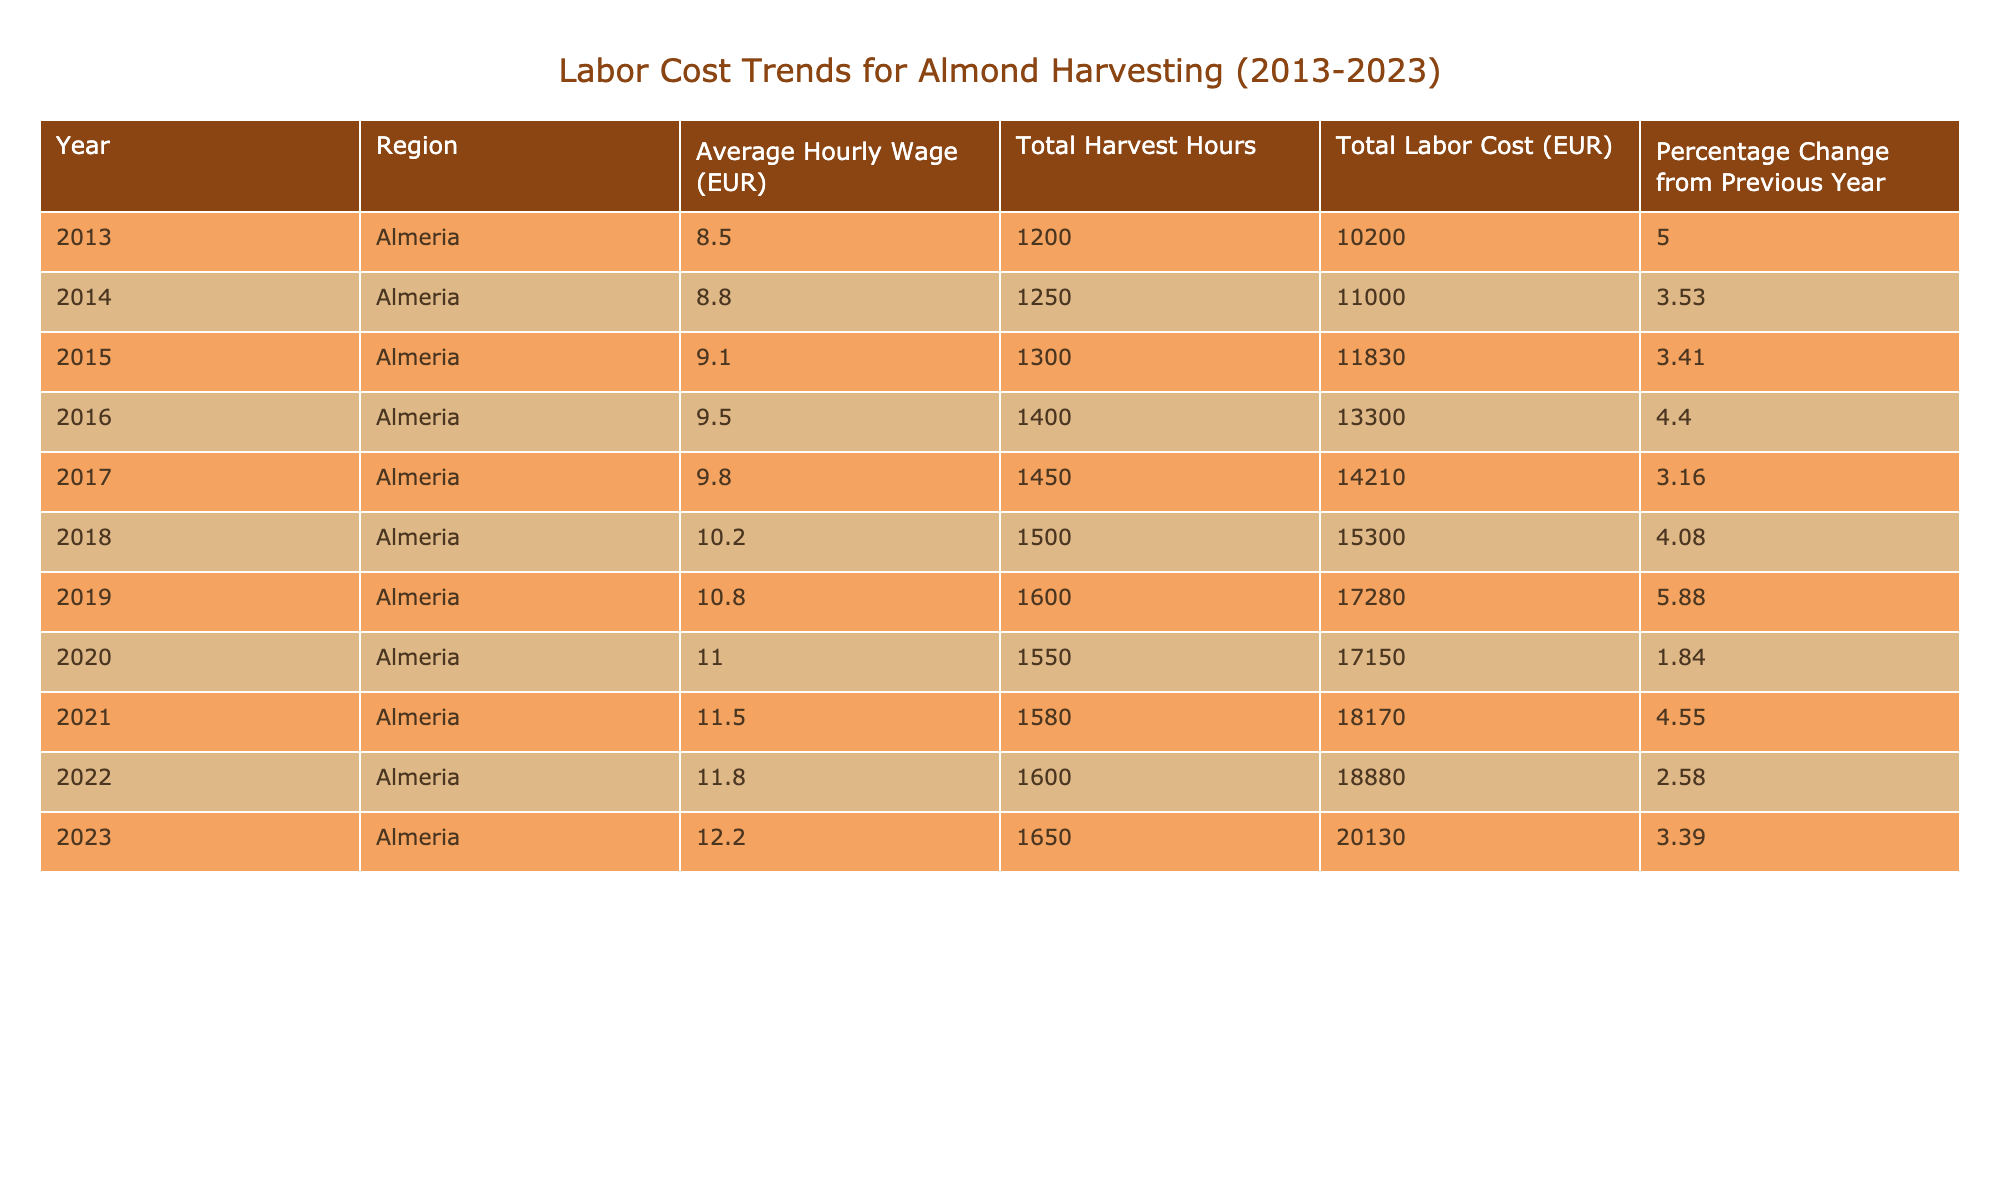What was the average hourly wage in 2013? The table shows that the average hourly wage in 2013 is located in the respective row for that year, which is 8.50 EUR.
Answer: 8.50 EUR What was the total labor cost for almond harvesting in 2020? By looking at the row for the year 2020, we can find that the total labor cost listed is 17150 EUR.
Answer: 17150 EUR What is the percentage change in average hourly wage from 2019 to 2020? The average hourly wage in 2019 was 10.80 EUR and in 2020 it was 11.00 EUR. The percentage change is calculated as ((11.00 - 10.80) / 10.80) * 100 = 1.85%, which we round to 1.84% based on the table data.
Answer: 1.84% Did the total labor cost increase every year from 2013 to 2023? To determine this, we review the total labor cost column for each year from 2013 to 2023 and find that there was a decrease in labor cost from 2019 to 2020 (17280 EUR to 17150 EUR). Therefore, the statement is false.
Answer: No What was the average percentage change from 2013 to 2023? To calculate this, we first sum all percentage changes from each year (5.00, 3.53, 3.41, 4.40, 3.16, 4.08, 5.88, 1.84, 4.55, 2.58, 3.39) and then divide by the number of changes (10), which gives us a total of 38.72%. Dividing this by 10 yields an average percentage change of 3.872%.
Answer: 3.87% What was the highest total labor cost recorded in the data? By reviewing the total labor costs from each year, we find the maximum value in the column is 20130 EUR for the year 2023.
Answer: 20130 EUR How many hours of labor were required for almond harvesting in 2018? The table states that the total harvest hours for the year 2018 is 1500 hours.
Answer: 1500 hours Was the average hourly wage in 2022 higher than in 2021? Checking the hourly wages for both years, we find 11.80 EUR for 2022 and 11.50 EUR for 2021. Since 11.80 > 11.50, the statement is true.
Answer: Yes What is the difference in total labor cost between 2015 and 2016? The total labor cost for 2015 was 11830 EUR and for 2016 it was 13300 EUR. The difference is calculated as 13300 - 11830 = 1470 EUR.
Answer: 1470 EUR 